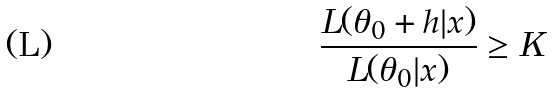Convert formula to latex. <formula><loc_0><loc_0><loc_500><loc_500>\frac { L ( \theta _ { 0 } + h | x ) } { L ( \theta _ { 0 } | x ) } \geq K</formula> 